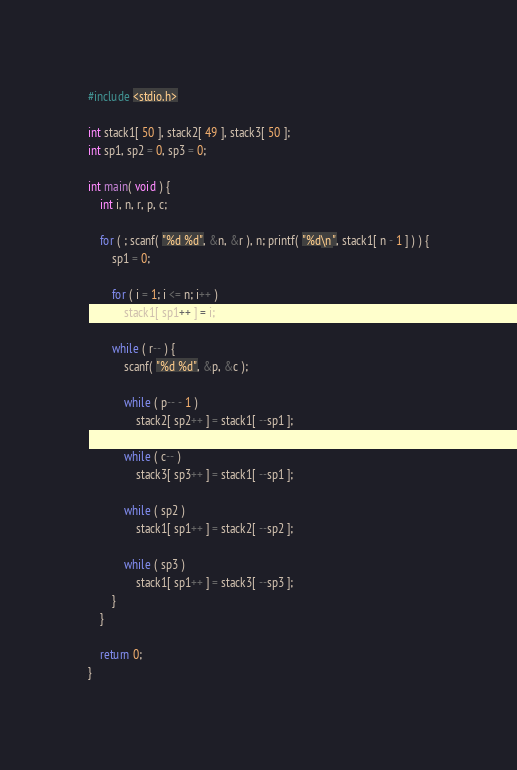<code> <loc_0><loc_0><loc_500><loc_500><_C_>#include <stdio.h>

int stack1[ 50 ], stack2[ 49 ], stack3[ 50 ];
int sp1, sp2 = 0, sp3 = 0;

int main( void ) {
	int i, n, r, p, c;

	for ( ; scanf( "%d %d", &n, &r ), n; printf( "%d\n", stack1[ n - 1 ] ) ) {
		sp1 = 0;

		for ( i = 1; i <= n; i++ )
			stack1[ sp1++ ] = i;

		while ( r-- ) {
			scanf( "%d %d", &p, &c );

			while ( p-- - 1 )
				stack2[ sp2++ ] = stack1[ --sp1 ];

			while ( c-- )
				stack3[ sp3++ ] = stack1[ --sp1 ];

			while ( sp2 )
				stack1[ sp1++ ] = stack2[ --sp2 ];

			while ( sp3 )
				stack1[ sp1++ ] = stack3[ --sp3 ];
		}
	}

	return 0;
}</code> 